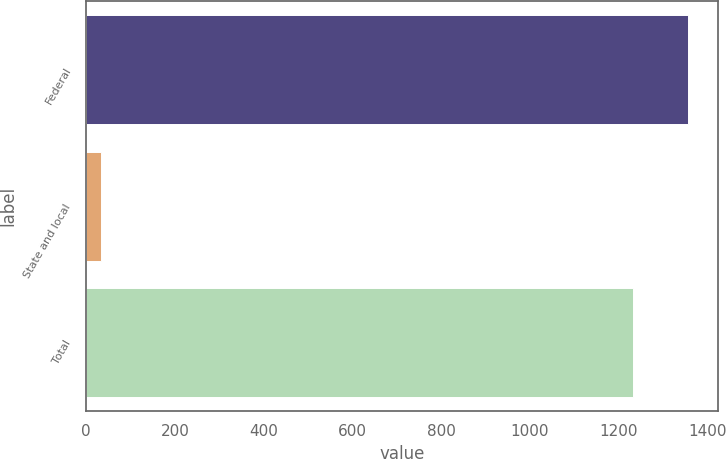<chart> <loc_0><loc_0><loc_500><loc_500><bar_chart><fcel>Federal<fcel>State and local<fcel>Total<nl><fcel>1356.7<fcel>33<fcel>1233<nl></chart> 